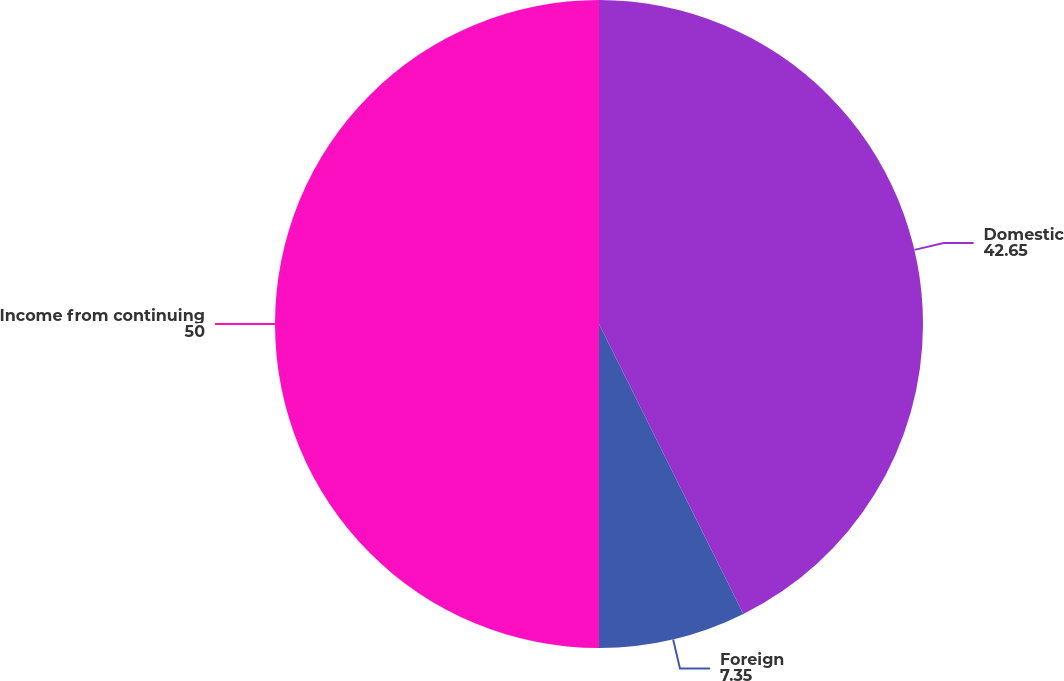<chart> <loc_0><loc_0><loc_500><loc_500><pie_chart><fcel>Domestic<fcel>Foreign<fcel>Income from continuing<nl><fcel>42.65%<fcel>7.35%<fcel>50.0%<nl></chart> 